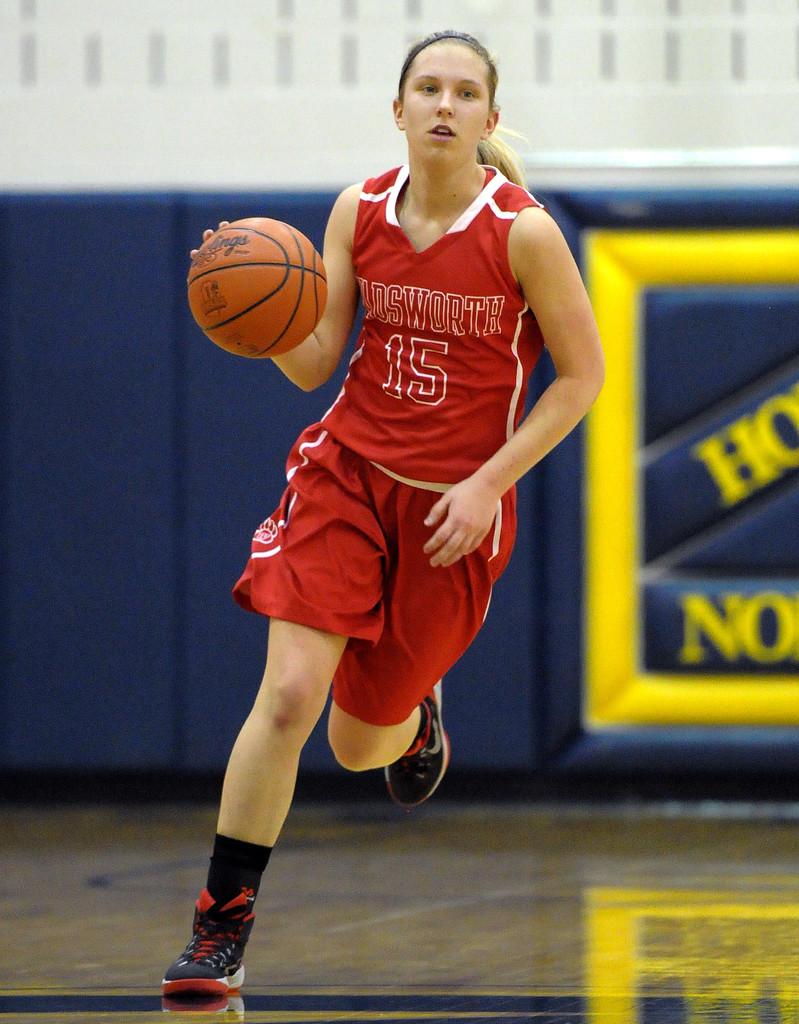Which player is that?
Your response must be concise. 15. 